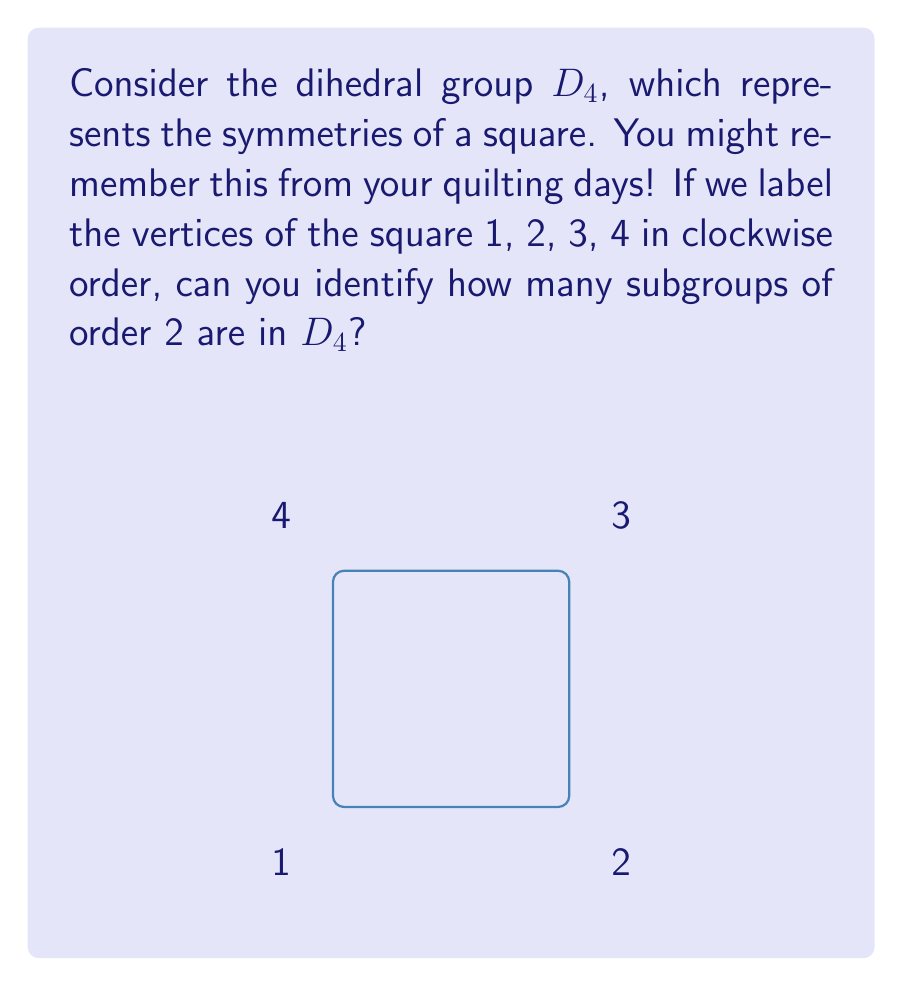Can you answer this question? Let's approach this step-by-step:

1) First, recall that $D_4$ has 8 elements in total:
   - The identity element (e)
   - Three 90-degree rotations ($r$, $r^2$, $r^3$)
   - Four reflections (let's call them $s$, $sr$, $sr^2$, $sr^3$)

2) A subgroup of order 2 will contain the identity element and one other element that, when applied twice, gives the identity.

3) Let's check each type of element:
   
   a) Rotations:
      - $r^2$ is the only rotation that, when applied twice, gives the identity.
      - So, $\{e, r^2\}$ is a subgroup of order 2.

   b) Reflections:
      - All reflections, when applied twice, give the identity.
      - So, $\{e, s\}$, $\{e, sr\}$, $\{e, sr^2\}$, and $\{e, sr^3\}$ are all subgroups of order 2.

4) In total, we have found 5 subgroups of order 2:
   - 1 subgroup containing a rotation
   - 4 subgroups containing reflections

Therefore, $D_4$ has 5 subgroups of order 2.
Answer: 5 